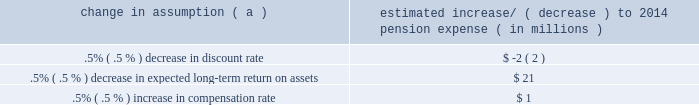The table below reflects the estimated effects on pension expense of certain changes in annual assumptions , using 2014 estimated expense as a baseline .
Table 29 : pension expense 2013 sensitivity analysis change in assumption ( a ) estimated increase/ ( decrease ) to 2014 pension expense ( in millions ) .
( a ) the impact is the effect of changing the specified assumption while holding all other assumptions constant .
Our pension plan contribution requirements are not particularly sensitive to actuarial assumptions .
Investment performance has the most impact on contribution requirements and will drive the amount of required contributions in future years .
Also , current law , including the provisions of the pension protection act of 2006 , sets limits as to both minimum and maximum contributions to the plan .
We do not expect to be required by law to make any contributions to the plan during 2014 .
We maintain other defined benefit plans that have a less significant effect on financial results , including various nonqualified supplemental retirement plans for certain employees , which are described more fully in note 15 employee benefit plans in the notes to consolidated financial statements in item 8 of this report .
Recourse and repurchase obligations as discussed in note 3 loan sale and servicing activities and variable interest entities in the notes to consolidated financial statements in item 8 of this report , pnc has sold commercial mortgage , residential mortgage and home equity loans directly or indirectly through securitization and loan sale transactions in which we have continuing involvement .
One form of continuing involvement includes certain recourse and loan repurchase obligations associated with the transferred assets .
Commercial mortgage loan recourse obligations we originate , close and service certain multi-family commercial mortgage loans which are sold to fnma under fnma 2019s delegated underwriting and servicing ( dus ) program .
We participated in a similar program with the fhlmc .
Our exposure and activity associated with these recourse obligations are reported in the corporate & institutional banking segment .
For more information regarding our commercial mortgage loan recourse obligations , see the recourse and repurchase obligations section of note 24 commitments and guarantees included in the notes to consolidated financial statements in item 8 of this report .
Residential mortgage repurchase obligations while residential mortgage loans are sold on a non-recourse basis , we assume certain loan repurchase obligations associated with mortgage loans we have sold to investors .
These loan repurchase obligations primarily relate to situations where pnc is alleged to have breached certain origination covenants and representations and warranties made to purchasers of the loans in the respective purchase and sale agreements .
Residential mortgage loans covered by these loan repurchase obligations include first and second-lien mortgage loans we have sold through agency securitizations , non-agency securitizations , and loan sale transactions .
As discussed in note 3 in the notes to consolidated financial statements in item 8 of this report , agency securitizations consist of mortgage loan sale transactions with fnma , fhlmc and the government national mortgage association ( gnma ) , while non-agency securitizations consist of mortgage loan sale transactions with private investors .
Mortgage loan sale transactions that are not part of a securitization may involve fnma , fhlmc or private investors .
Our historical exposure and activity associated with agency securitization repurchase obligations has primarily been related to transactions with fnma and fhlmc , as indemnification and repurchase losses associated with fha and va-insured and uninsured loans pooled in gnma securitizations historically have been minimal .
Repurchase obligation activity associated with residential mortgages is reported in the residential mortgage banking segment .
Loan covenants and representations and warranties are established through loan sale agreements with various investors to provide assurance that pnc has sold loans that are of sufficient investment quality .
Key aspects of such covenants and representations and warranties include the loan 2019s compliance with any applicable loan criteria established for the transaction , including underwriting standards , delivery of all required loan documents to the investor or its designated party , sufficient collateral valuation and the validity of the lien securing the loan .
As a result of alleged breaches of these contractual obligations , investors may request pnc to indemnify them against losses on certain loans or to repurchase loans .
We investigate every investor claim on a loan by loan basis to determine the existence of a legitimate claim and that all other conditions for indemnification or repurchase have been met prior to the settlement with that investor .
Indemnifications for loss or loan repurchases typically occur when , after review of the claim , we agree insufficient evidence exists to dispute the investor 2019s claim that a breach of a loan covenant and representation and warranty has occurred , such breach has not been cured and the effect of such breach is deemed to have had a material and adverse effect on the value of the transferred loan .
Depending on the sale agreement and upon proper notice from the investor , we typically respond to such indemnification and repurchase requests within 60 days , although final resolution of the claim may take a longer period of time .
With the exception of the sales agreements associated the pnc financial services group , inc .
2013 form 10-k 67 .
For 2014 , is the pension expense impact of a .5% ( .5 % ) decrease in expected long-term return on assets larger than a .5% ( .5 % ) increase in compensation rate? 
Computations: (21 > 1)
Answer: yes. 